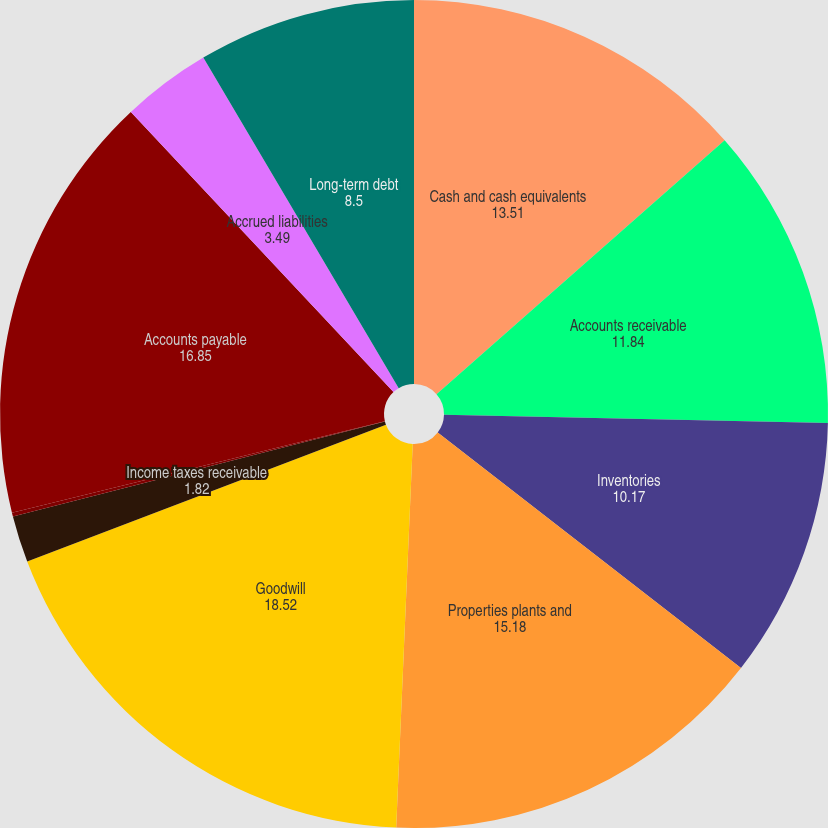Convert chart. <chart><loc_0><loc_0><loc_500><loc_500><pie_chart><fcel>Cash and cash equivalents<fcel>Accounts receivable<fcel>Inventories<fcel>Properties plants and<fcel>Goodwill<fcel>Income taxes receivable<fcel>Other assets<fcel>Accounts payable<fcel>Accrued liabilities<fcel>Long-term debt<nl><fcel>13.51%<fcel>11.84%<fcel>10.17%<fcel>15.18%<fcel>18.52%<fcel>1.82%<fcel>0.15%<fcel>16.85%<fcel>3.49%<fcel>8.5%<nl></chart> 